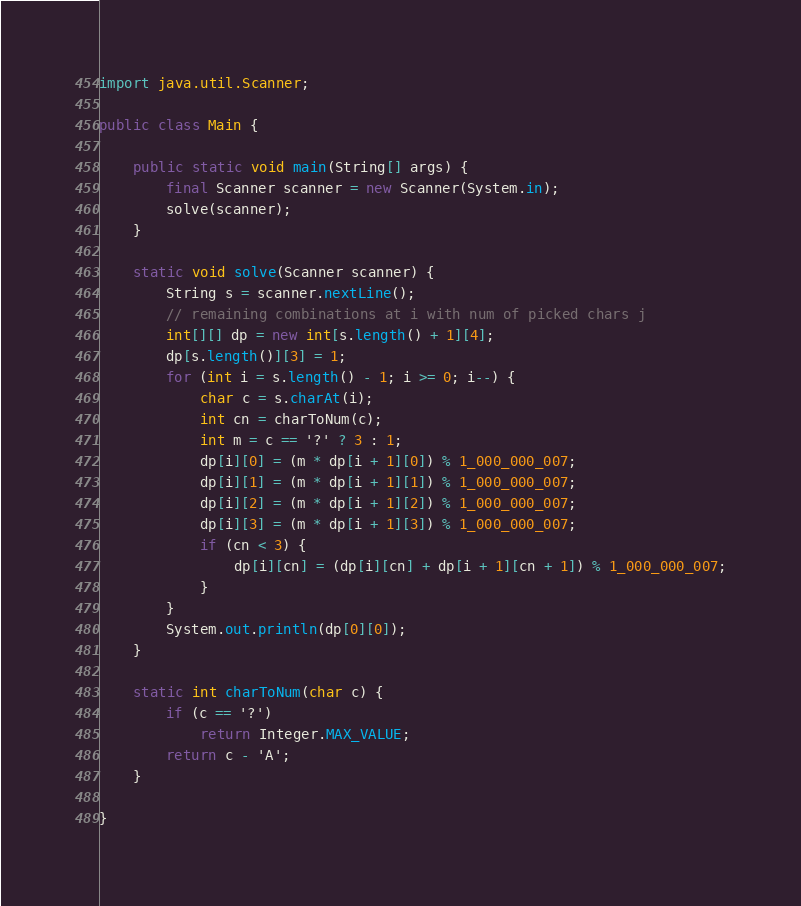<code> <loc_0><loc_0><loc_500><loc_500><_Java_>import java.util.Scanner;

public class Main {

    public static void main(String[] args) {
        final Scanner scanner = new Scanner(System.in);
        solve(scanner);
    }

    static void solve(Scanner scanner) {
        String s = scanner.nextLine();
        // remaining combinations at i with num of picked chars j
        int[][] dp = new int[s.length() + 1][4];
        dp[s.length()][3] = 1;
        for (int i = s.length() - 1; i >= 0; i--) {
            char c = s.charAt(i);
            int cn = charToNum(c);
            int m = c == '?' ? 3 : 1;
            dp[i][0] = (m * dp[i + 1][0]) % 1_000_000_007;
            dp[i][1] = (m * dp[i + 1][1]) % 1_000_000_007;
            dp[i][2] = (m * dp[i + 1][2]) % 1_000_000_007;
            dp[i][3] = (m * dp[i + 1][3]) % 1_000_000_007;
            if (cn < 3) {
                dp[i][cn] = (dp[i][cn] + dp[i + 1][cn + 1]) % 1_000_000_007;
            }
        }
        System.out.println(dp[0][0]);
    }

    static int charToNum(char c) {
        if (c == '?')
            return Integer.MAX_VALUE;
        return c - 'A';
    }

}</code> 